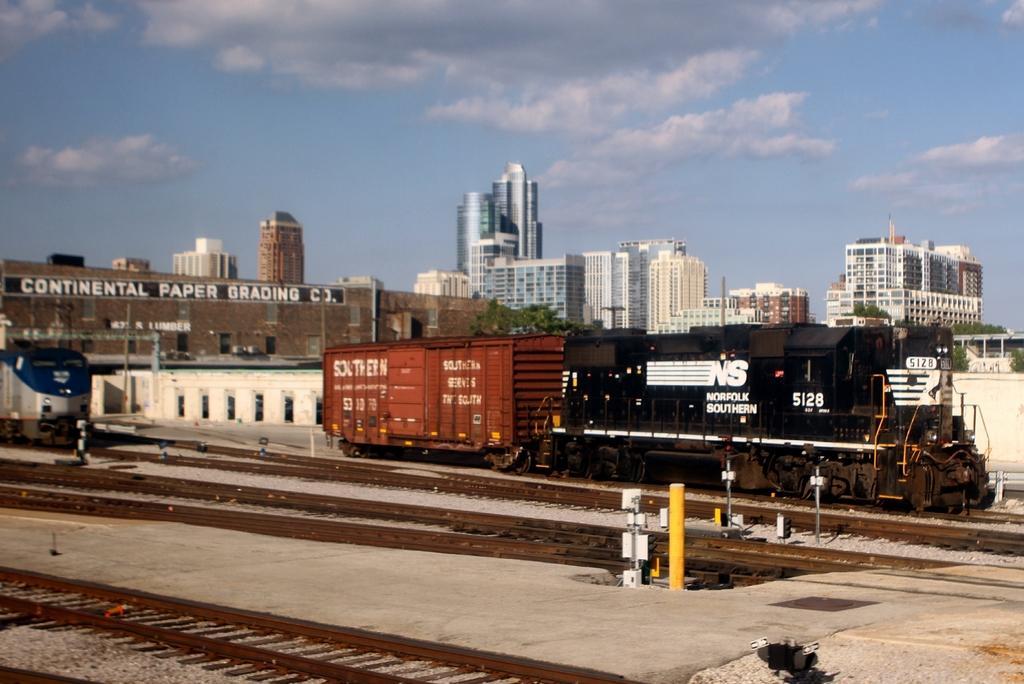Please provide a concise description of this image. This picture is clicked outside. In the foreground we can see the railway tracks, gravel and the metal objects. In the center we can see the trains seems to be running on the railway tracks and we can see the trees, buildings and we can see the text on the building. In the background we can see the sky with the clouds and we can see the skyscrapers. 